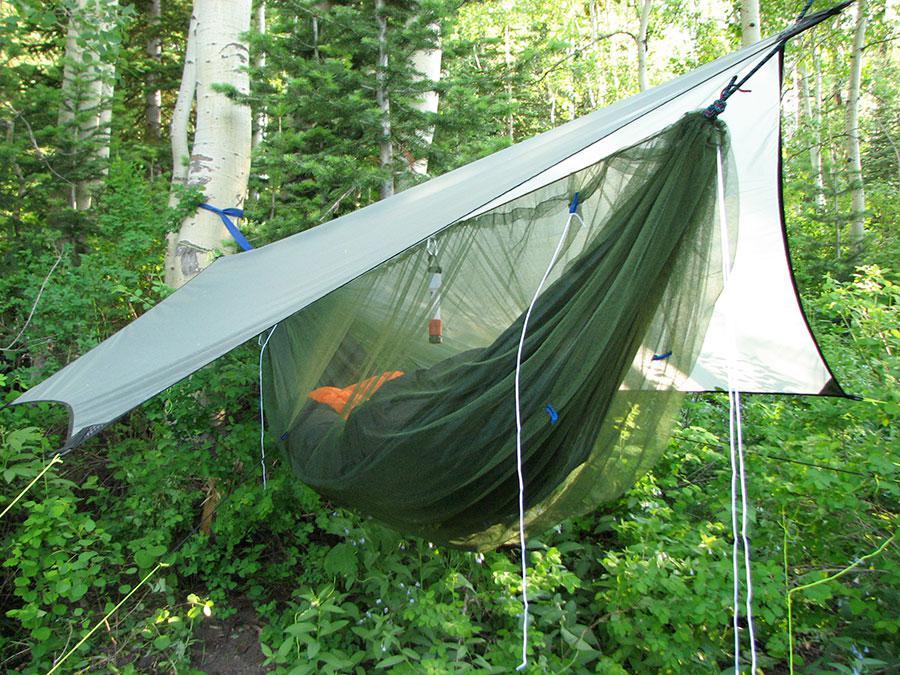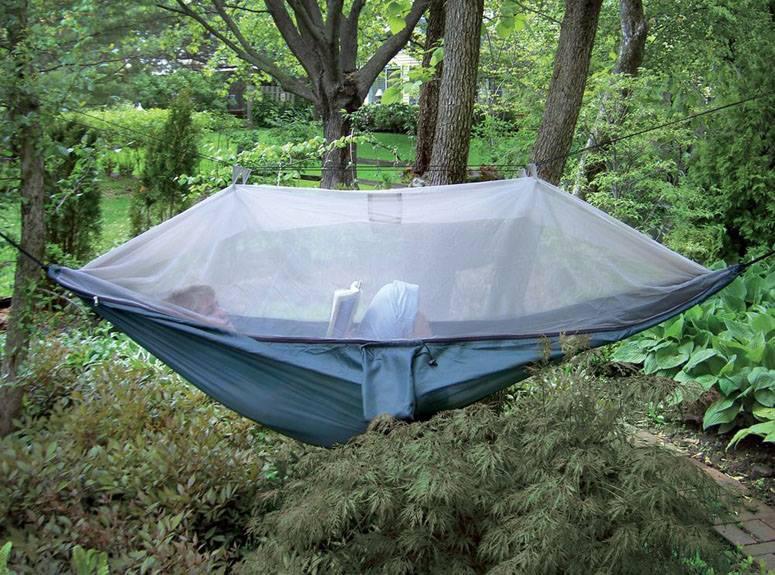The first image is the image on the left, the second image is the image on the right. Evaluate the accuracy of this statement regarding the images: "A person can be seen in one image of a hanging hammock with netting cover.". Is it true? Answer yes or no. Yes. 